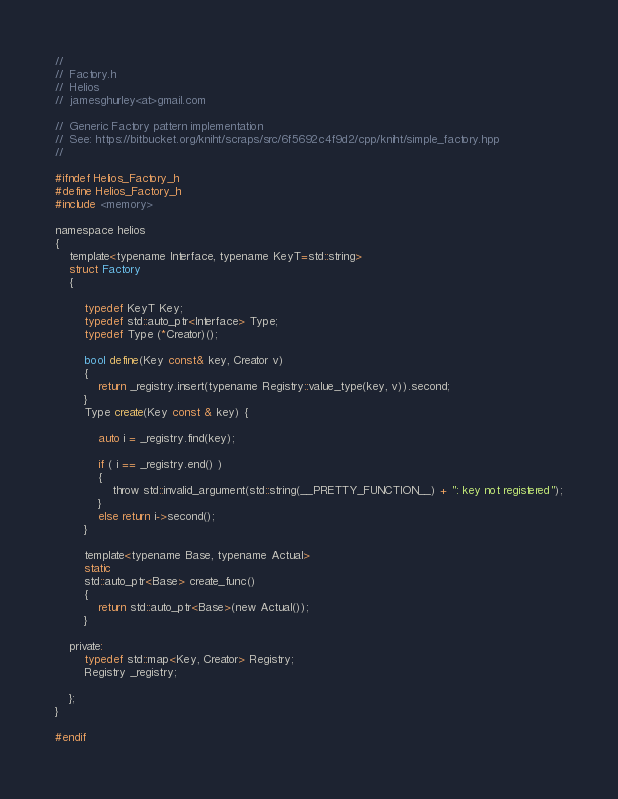<code> <loc_0><loc_0><loc_500><loc_500><_C_>//
//  Factory.h
//  Helios
//  jamesghurley<at>gmail.com

//  Generic Factory pattern implementation
//  See: https://bitbucket.org/kniht/scraps/src/6f5692c4f9d2/cpp/kniht/simple_factory.hpp
//

#ifndef Helios_Factory_h
#define Helios_Factory_h
#include <memory>

namespace helios
{
    template<typename Interface, typename KeyT=std::string>
    struct Factory
    {
        
        typedef KeyT Key;
        typedef std::auto_ptr<Interface> Type;
        typedef Type (*Creator)();
        
        bool define(Key const& key, Creator v) 
        {
            return _registry.insert(typename Registry::value_type(key, v)).second;
        }
        Type create(Key const & key) {
            
            auto i = _registry.find(key);
            
            if ( i == _registry.end() )
            {
                throw std::invalid_argument(std::string(__PRETTY_FUNCTION__) + ": key not registered");
            }
            else return i->second();
        }
        
        template<typename Base, typename Actual>
        static
        std::auto_ptr<Base> create_func() 
        {
            return std::auto_ptr<Base>(new Actual());
        }
                                    
    private:
        typedef std::map<Key, Creator> Registry;
        Registry _registry;
                                    
    };
}

#endif
</code> 